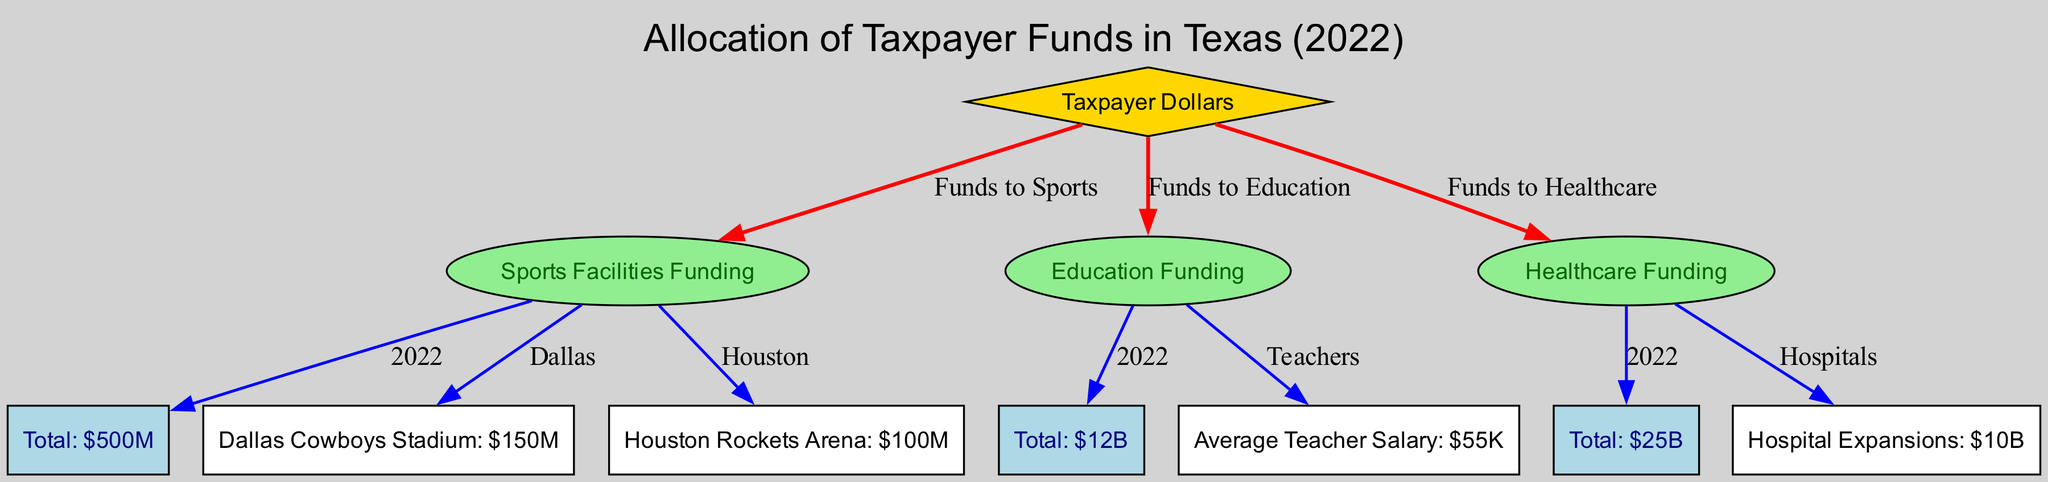What is the total amount allocated to sports facilities in 2022? The node labeled "Total: $500M" represents the total funding allocated to sports facilities for the year 2022 in the diagram.
Answer: $500M How much funding is allocated to healthcare? The node labeled "Total: $25B" shows the total funding allocated to healthcare.
Answer: $25B What percentage of taxpayer dollars is spent on sports compared to education funding? The diagram indicates that $500M is allocated to sports facilities and $12B to education funding. To find the percentage, the calculation is (500M / 12B) * 100, which results in approximately 4.17%.
Answer: 4.17% How many local sports facilities are listed specifically in the diagram? The diagram includes two local sports facilities: Dallas Cowboys Stadium and Houston Rockets Arena, which can be counted to determine the total listed facilities.
Answer: 2 Which category has the least funding from taxpayer dollars? Comparing "Sports Facilities Funding" ($500M), "Education Funding" ($12B), and "Healthcare Funding" ($25B), sports facilities have the least amount allocated.
Answer: Sports Facilities Funding What is the average teacher salary according to the diagram? The node labeled "Average Teacher Salary: $55K" provides the average teacher salary information directly from the education funding category.
Answer: $55K If the hospital expansion receives a funding of $10B, how does it compare to the total education funding? The total education funding is $12B, and the hospital expansion funding of $10B is subtracted from the education funding. While $10B is lesser than $12B, it shows that a significant portion of taxpayer dollars goes toward healthcare as well.
Answer: Lesser Which city received the highest funding for its sports facility? The diagram states that the Dallas Cowboys Stadium received $150M, while the Houston Rockets Arena received $100M; therefore, Dallas Cowboys Stadium has the highest amount.
Answer: Dallas Cowboys Stadium What relationship exists between taxpayer dollars and healthcare funding? The edge labeled "Funds to Healthcare" connects the node "taxpayer dollars" to the node "healthcare funding," indicating that taxpayer dollars are allocated to healthcare funding.
Answer: Funds to Healthcare 